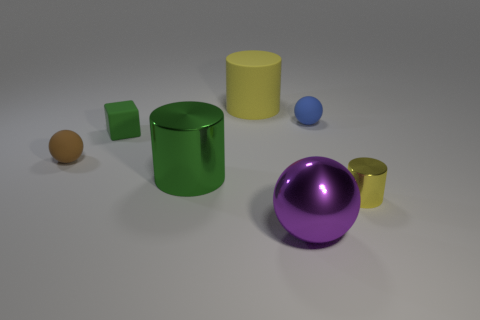Is the large metal cylinder the same color as the tiny cube?
Keep it short and to the point. Yes. There is a tiny cylinder that is the same color as the large rubber object; what material is it?
Make the answer very short. Metal. There is a cylinder on the right side of the large sphere; are there any small objects that are on the right side of it?
Provide a succinct answer. No. What number of cubes are either metallic things or green rubber things?
Provide a succinct answer. 1. Are there any green shiny things that have the same shape as the tiny brown thing?
Offer a very short reply. No. What is the shape of the yellow metallic object?
Your answer should be very brief. Cylinder. How many objects are gray matte cylinders or green matte objects?
Your answer should be compact. 1. Does the matte sphere that is left of the tiny green object have the same size as the cylinder that is behind the small brown rubber sphere?
Your answer should be compact. No. What number of other things are made of the same material as the brown sphere?
Offer a very short reply. 3. Are there more tiny green rubber things on the left side of the tiny rubber cube than large yellow matte cylinders behind the small blue ball?
Your response must be concise. No. 